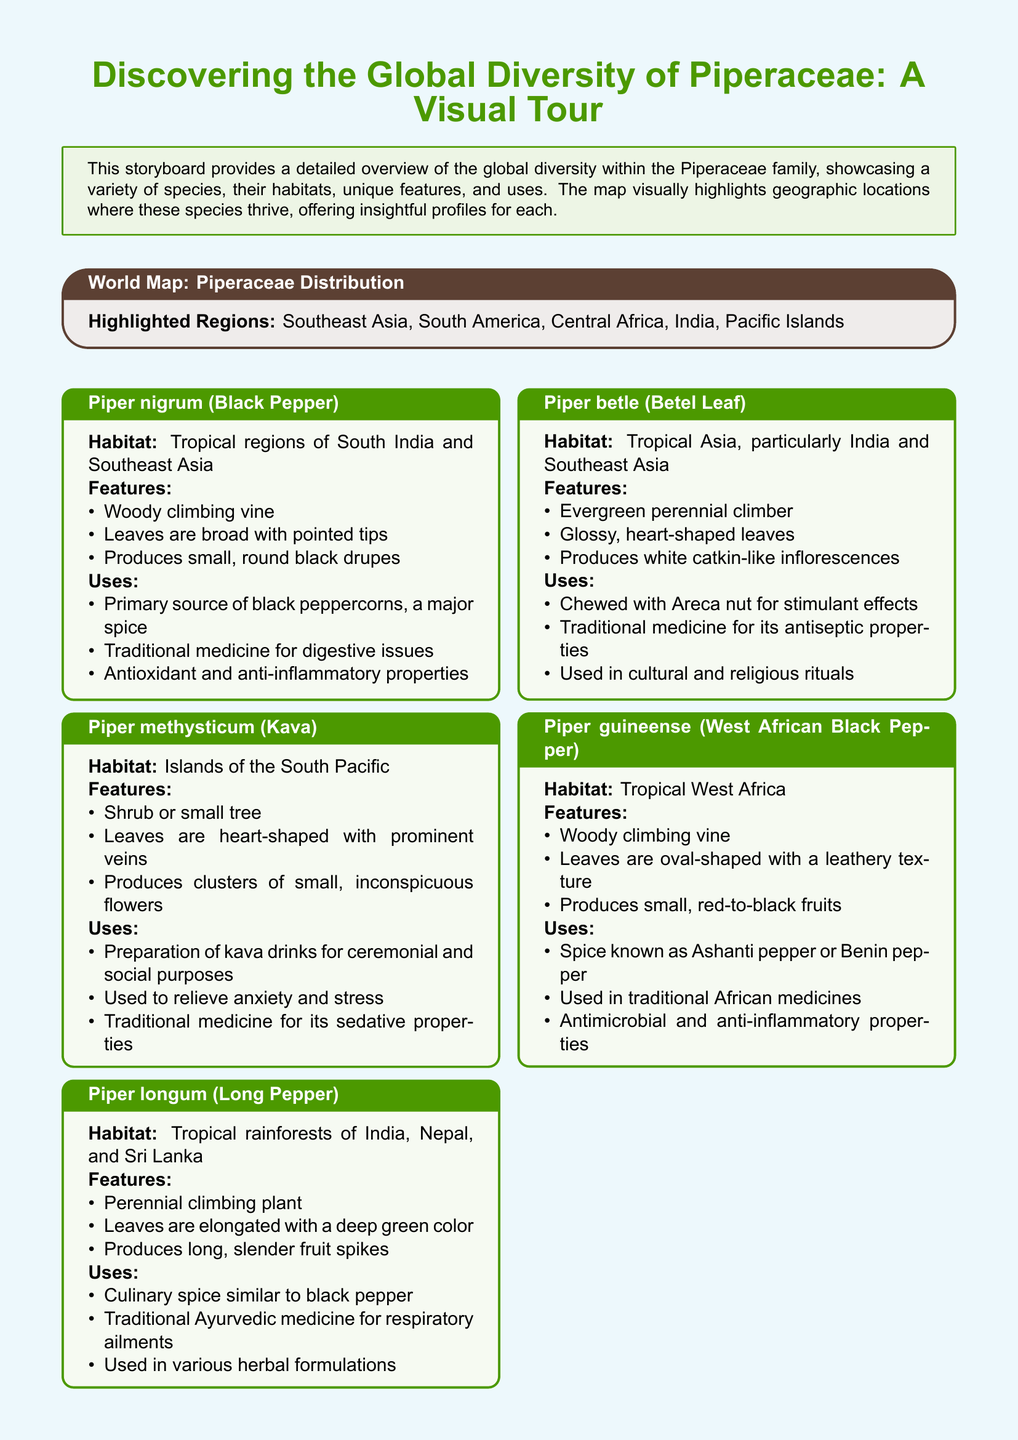What is the title of the storyboard? The title of the storyboard is prominently displayed at the top of the document.
Answer: Discovering the Global Diversity of Piperaceae: A Visual Tour Which regions are highlighted on the world map? The highlighted regions are specified in the map section of the document.
Answer: Southeast Asia, South America, Central Africa, India, Pacific Islands What species is known as Black Pepper? The document provides a common name for the species as one of the species profiles.
Answer: Piper nigrum What is the habitat of Piper methysticum? The habitat is mentioned in the species profile section of the document for Piper methysticum.
Answer: Islands of the South Pacific How is Piper longum used in traditional medicine? The uses section for Piper longum details its role in traditional practices.
Answer: Respiratory ailments Which feature is common to the leaves of Piper betle? The features section describes the distinctive characteristics of Piper betle leaves.
Answer: Glossy, heart-shaped leaves What type of plant is Piper guineense? The document states the growth form of Piper guineense in its species profile.
Answer: Woody climbing vine How many species profiles are included in the storyboard? The total number of species profiles can be counted based on the sections in the document.
Answer: Five 